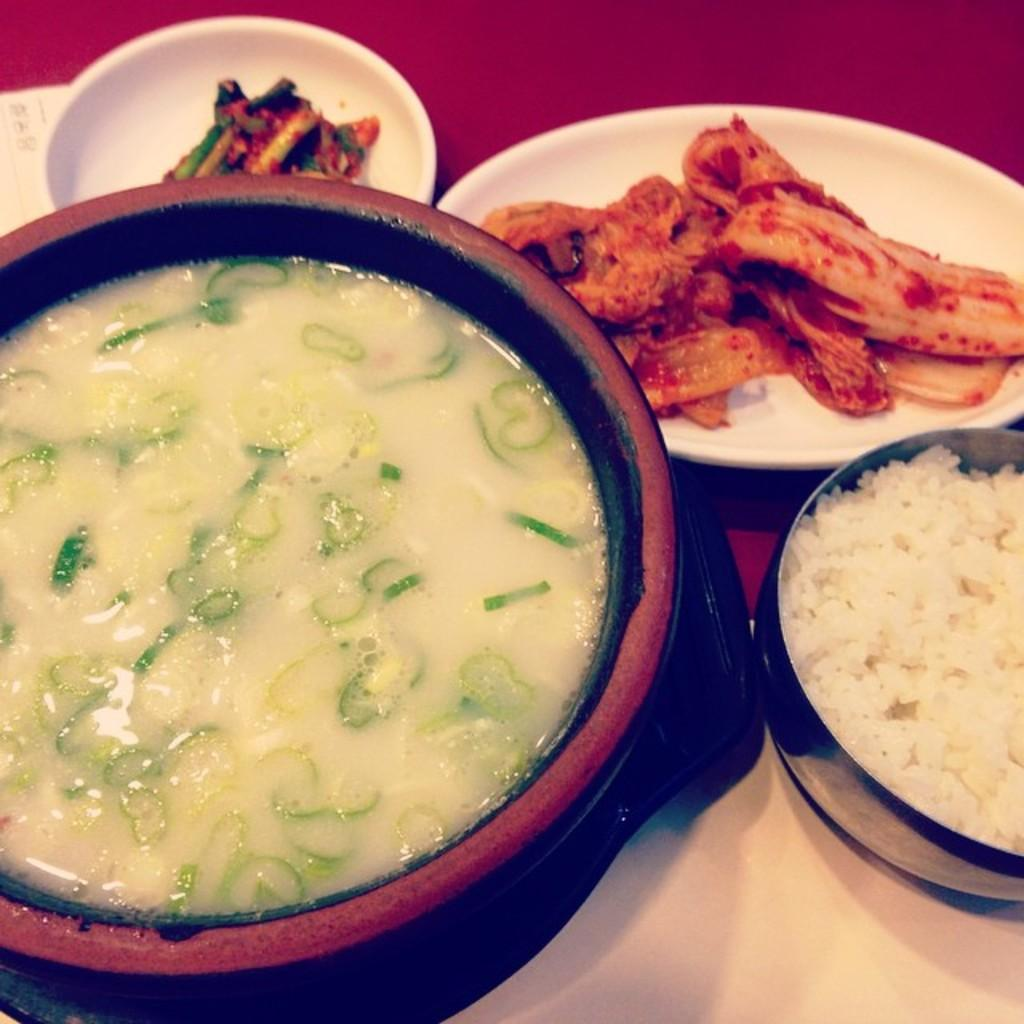What is in the bowls that are visible in the image? There are bowls containing food in the image. Where are the bowls located? The bowls are placed on a surface. What can be seen in the background of the image? There is paper visible in the background of the image. What type of birthday card can be seen in the image? There is no birthday card present in the image. Can you tell me how many needles are used to create the pattern on the paper in the background? There is no pattern made of needles on the paper in the background; it is simply paper. 